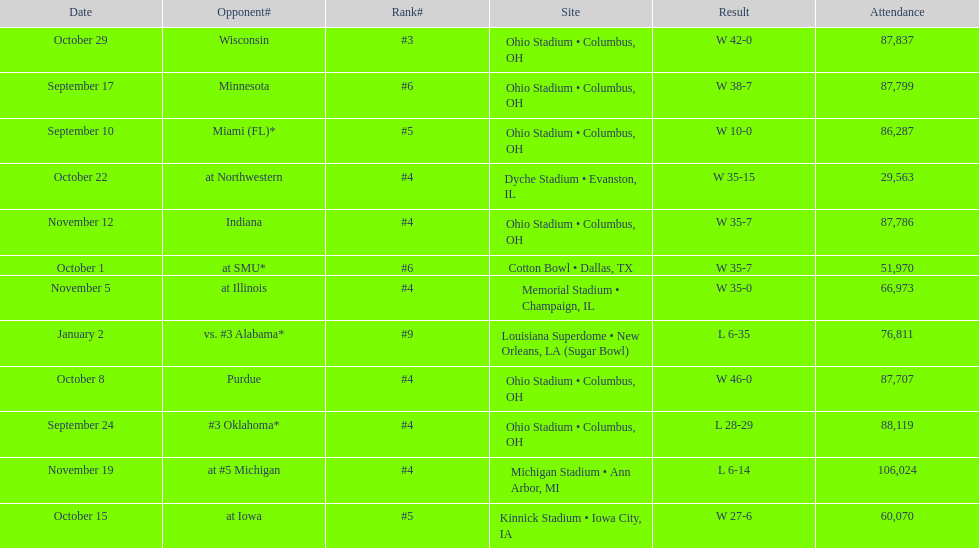Would you mind parsing the complete table? {'header': ['Date', 'Opponent#', 'Rank#', 'Site', 'Result', 'Attendance'], 'rows': [['October 29', 'Wisconsin', '#3', 'Ohio Stadium • Columbus, OH', 'W\xa042-0', '87,837'], ['September 17', 'Minnesota', '#6', 'Ohio Stadium • Columbus, OH', 'W\xa038-7', '87,799'], ['September 10', 'Miami (FL)*', '#5', 'Ohio Stadium • Columbus, OH', 'W\xa010-0', '86,287'], ['October 22', 'at\xa0Northwestern', '#4', 'Dyche Stadium • Evanston, IL', 'W\xa035-15', '29,563'], ['November 12', 'Indiana', '#4', 'Ohio Stadium • Columbus, OH', 'W\xa035-7', '87,786'], ['October 1', 'at\xa0SMU*', '#6', 'Cotton Bowl • Dallas, TX', 'W\xa035-7', '51,970'], ['November 5', 'at\xa0Illinois', '#4', 'Memorial Stadium • Champaign, IL', 'W\xa035-0', '66,973'], ['January 2', 'vs.\xa0#3\xa0Alabama*', '#9', 'Louisiana Superdome • New Orleans, LA (Sugar Bowl)', 'L\xa06-35', '76,811'], ['October 8', 'Purdue', '#4', 'Ohio Stadium • Columbus, OH', 'W\xa046-0', '87,707'], ['September 24', '#3\xa0Oklahoma*', '#4', 'Ohio Stadium • Columbus, OH', 'L\xa028-29', '88,119'], ['November 19', 'at\xa0#5\xa0Michigan', '#4', 'Michigan Stadium • Ann Arbor, MI', 'L\xa06-14', '106,024'], ['October 15', 'at\xa0Iowa', '#5', 'Kinnick Stadium • Iowa City, IA', 'W\xa027-6', '60,070']]} Which date was attended by the most people? November 19. 